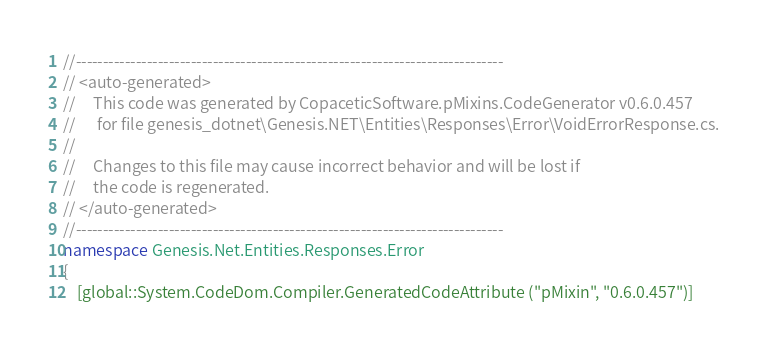Convert code to text. <code><loc_0><loc_0><loc_500><loc_500><_C#_>//------------------------------------------------------------------------------
// <auto-generated>
//     This code was generated by CopaceticSoftware.pMixins.CodeGenerator v0.6.0.457
//      for file genesis_dotnet\Genesis.NET\Entities\Responses\Error\VoidErrorResponse.cs.
//
//     Changes to this file may cause incorrect behavior and will be lost if 
//     the code is regenerated.  
// </auto-generated> 
//------------------------------------------------------------------------------
namespace Genesis.Net.Entities.Responses.Error
{
	[global::System.CodeDom.Compiler.GeneratedCodeAttribute ("pMixin", "0.6.0.457")]</code> 